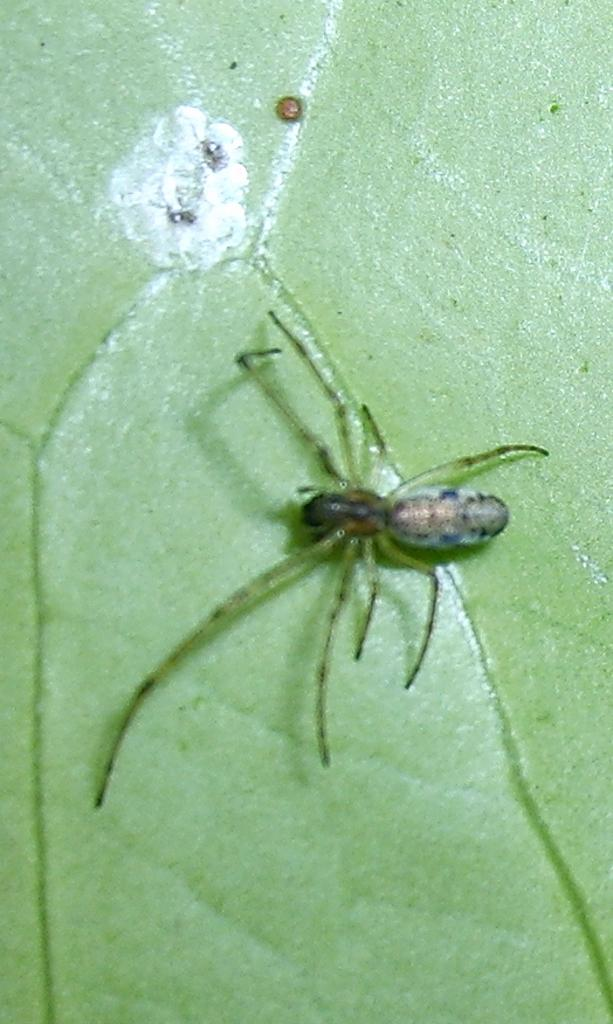What type of creature is present in the image? There is an insect in the image. What is the insect laying on in the image? The insect is laying on a green surface. What type of vessel is the insect using to sail across the green surface in the image? There is no vessel present in the image, and the insect is not sailing across the green surface. What type of health benefits can be derived from the insect in the image? There is no indication in the image that the insect has any health benefits. 